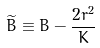<formula> <loc_0><loc_0><loc_500><loc_500>\widetilde { B } \equiv B - \frac { 2 r ^ { 2 } } K</formula> 